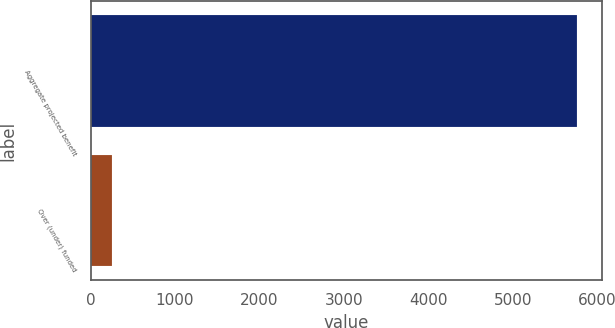<chart> <loc_0><loc_0><loc_500><loc_500><bar_chart><fcel>Aggregate projected benefit<fcel>Over (under) funded<nl><fcel>5766<fcel>248<nl></chart> 